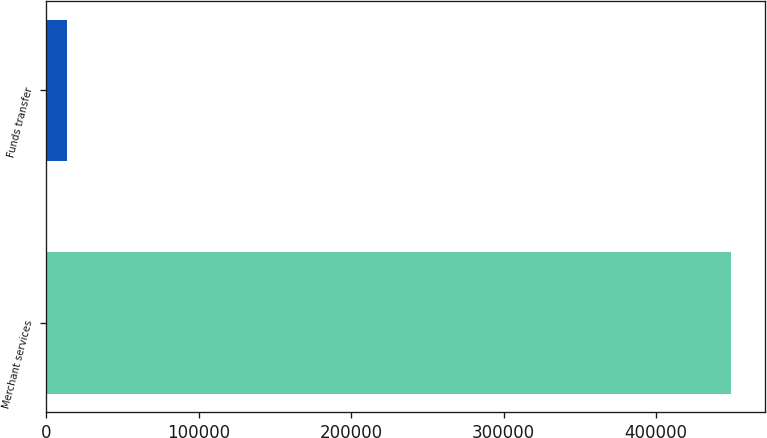Convert chart to OTSL. <chart><loc_0><loc_0><loc_500><loc_500><bar_chart><fcel>Merchant services<fcel>Funds transfer<nl><fcel>449144<fcel>13682<nl></chart> 